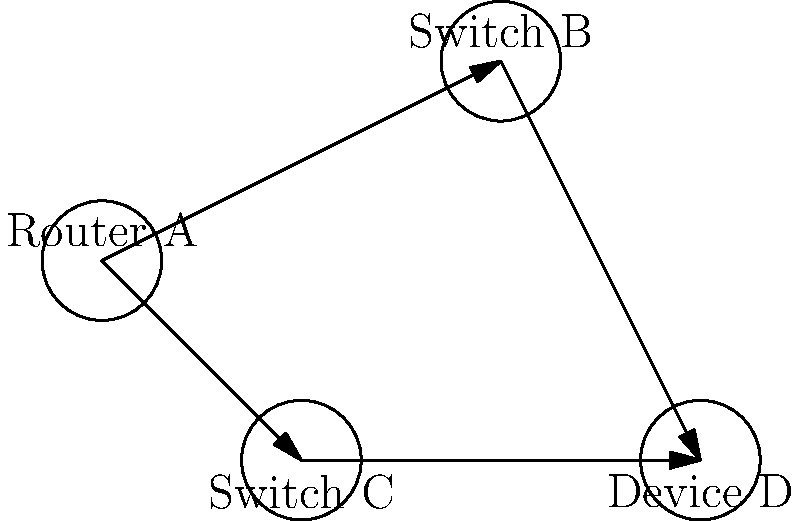In the network diagram above, a data packet needs to be sent from Router A to Device D. Considering that routers make decisions based on the most efficient path and switches forward data to all connected devices, how many different paths can the data packet take to reach Device D? Let's break down the possible paths step-by-step:

1. The data packet starts at Router A.

2. Router A has two options for the next hop:
   a. It can send the packet to Switch B
   b. It can send the packet to Switch C

3. If the packet goes to Switch B:
   - Switch B will directly forward the packet to Device D

4. If the packet goes to Switch C:
   - Switch C will directly forward the packet to Device D

5. Both paths (A → B → D and A → C → D) are equally valid and have the same number of hops.

6. Since there are two distinct paths from Router A to Device D, and no other possible routes, the total number of different paths is 2.

This simple network topology demonstrates how data can take multiple paths to reach its destination, which is a fundamental concept in network redundancy and load balancing.
Answer: 2 paths 